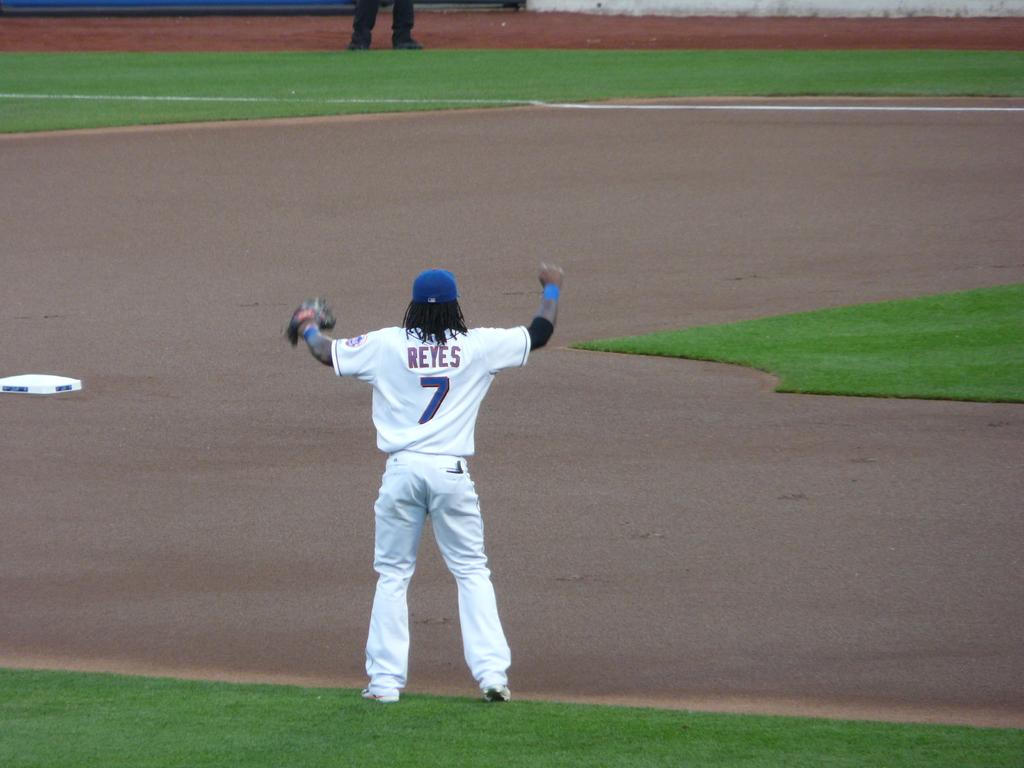What number is this player?
Keep it short and to the point. 7. 